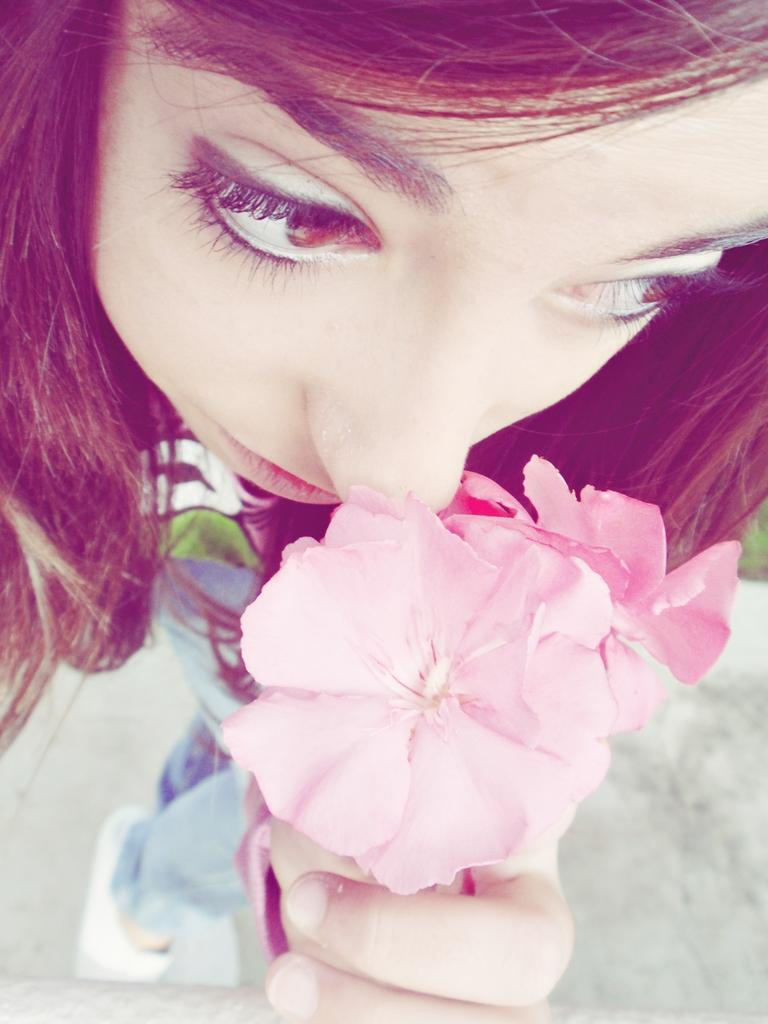Who is the main subject in the image? There is a woman in the image. What is the woman holding in the image? The woman is holding pink flowers. What type of clothing is the woman wearing on her lower body? The woman is wearing jeans. What type of footwear is the woman wearing in the image? The woman is wearing white shoes. What type of pet is the woman holding in the image? There is no pet visible in the image; the woman is holding pink flowers. 